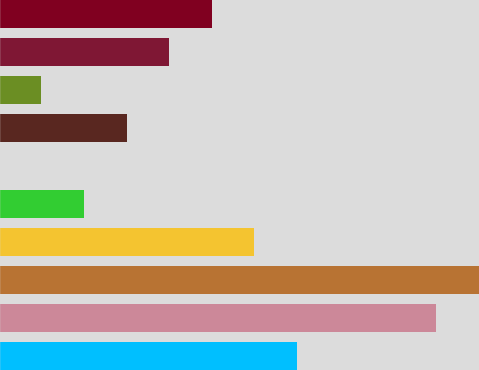Convert chart to OTSL. <chart><loc_0><loc_0><loc_500><loc_500><bar_chart><fcel>Year ended December 31 (in<fcel>Issued - balance at January 1<fcel>Total issued - balance at<fcel>Treasury - balance at January<fcel>Purchase of treasury stock<fcel>Share repurchases related to<fcel>Employee benefits and<fcel>Employee stock purchase plans<fcel>Total issued from treasury<fcel>Total treasury - balance at<nl><fcel>2873.49<fcel>4214.47<fcel>4624.94<fcel>2463.02<fcel>821.14<fcel>0.2<fcel>1231.61<fcel>410.67<fcel>1642.08<fcel>2052.55<nl></chart> 